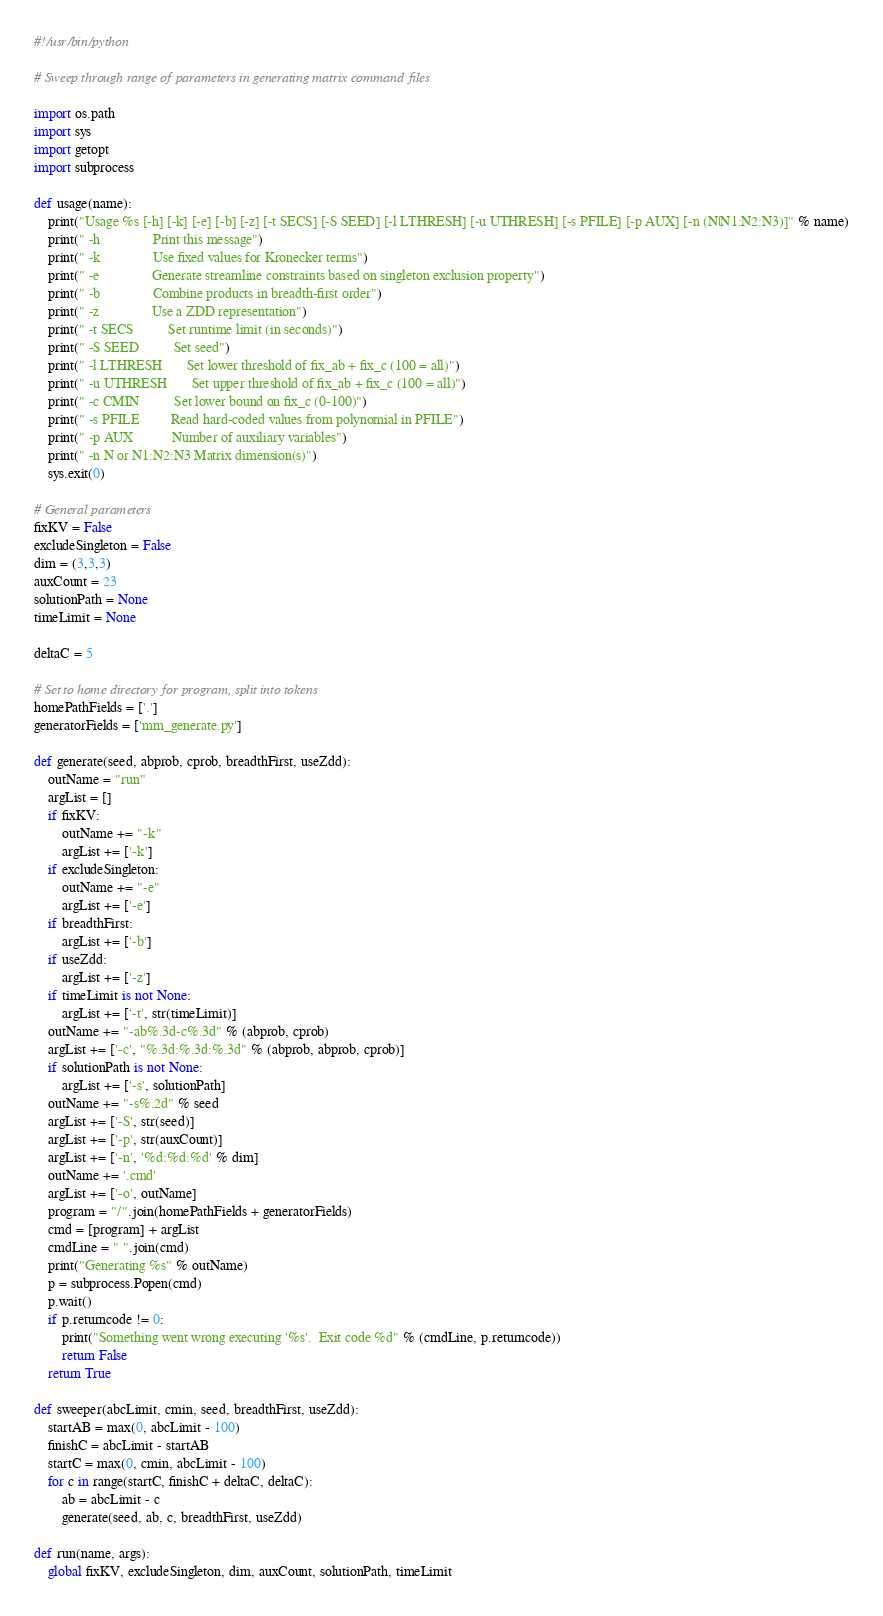Convert code to text. <code><loc_0><loc_0><loc_500><loc_500><_Python_>#!/usr/bin/python

# Sweep through range of parameters in generating matrix command files

import os.path
import sys
import getopt
import subprocess

def usage(name):
    print("Usage %s [-h] [-k] [-e] [-b] [-z] [-t SECS] [-S SEED] [-l LTHRESH] [-u UTHRESH] [-s PFILE] [-p AUX] [-n (N|N1:N2:N3)]" % name)
    print(" -h               Print this message")
    print(" -k               Use fixed values for Kronecker terms")
    print(" -e               Generate streamline constraints based on singleton exclusion property")
    print(" -b               Combine products in breadth-first order")
    print(" -z               Use a ZDD representation")
    print(" -t SECS          Set runtime limit (in seconds)")
    print(" -S SEED          Set seed")
    print(" -l LTHRESH       Set lower threshold of fix_ab + fix_c (100 = all)")
    print(" -u UTHRESH       Set upper threshold of fix_ab + fix_c (100 = all)")
    print(" -c CMIN          Set lower bound on fix_c (0-100)")
    print(" -s PFILE         Read hard-coded values from polynomial in PFILE")
    print(" -p AUX           Number of auxiliary variables")
    print(" -n N or N1:N2:N3 Matrix dimension(s)")
    sys.exit(0)

# General parameters
fixKV = False
excludeSingleton = False
dim = (3,3,3)
auxCount = 23
solutionPath = None
timeLimit = None

deltaC = 5

# Set to home directory for program, split into tokens
homePathFields = ['.']
generatorFields = ['mm_generate.py']

def generate(seed, abprob, cprob, breadthFirst, useZdd):
    outName = "run"
    argList = []
    if fixKV:
        outName += "-k"
        argList += ['-k']
    if excludeSingleton:
        outName += "-e"
        argList += ['-e']
    if breadthFirst:
        argList += ['-b']
    if useZdd:
        argList += ['-z']
    if timeLimit is not None:
        argList += ['-t', str(timeLimit)]
    outName += "-ab%.3d-c%.3d" % (abprob, cprob)
    argList += ['-c', "%.3d:%.3d:%.3d" % (abprob, abprob, cprob)]
    if solutionPath is not None:
        argList += ['-s', solutionPath]
    outName += "-s%.2d" % seed
    argList += ['-S', str(seed)]
    argList += ['-p', str(auxCount)]
    argList += ['-n', '%d:%d:%d' % dim]
    outName += '.cmd'
    argList += ['-o', outName]
    program = "/".join(homePathFields + generatorFields)
    cmd = [program] + argList
    cmdLine = " ".join(cmd)
    print("Generating %s" % outName)
    p = subprocess.Popen(cmd)
    p.wait()
    if p.returncode != 0:
        print("Something went wrong executing '%s'.  Exit code %d" % (cmdLine, p.returncode))
        return False
    return True
    
def sweeper(abcLimit, cmin, seed, breadthFirst, useZdd):
    startAB = max(0, abcLimit - 100)
    finishC = abcLimit - startAB
    startC = max(0, cmin, abcLimit - 100)
    for c in range(startC, finishC + deltaC, deltaC):
        ab = abcLimit - c
        generate(seed, ab, c, breadthFirst, useZdd)

def run(name, args):
    global fixKV, excludeSingleton, dim, auxCount, solutionPath, timeLimit</code> 